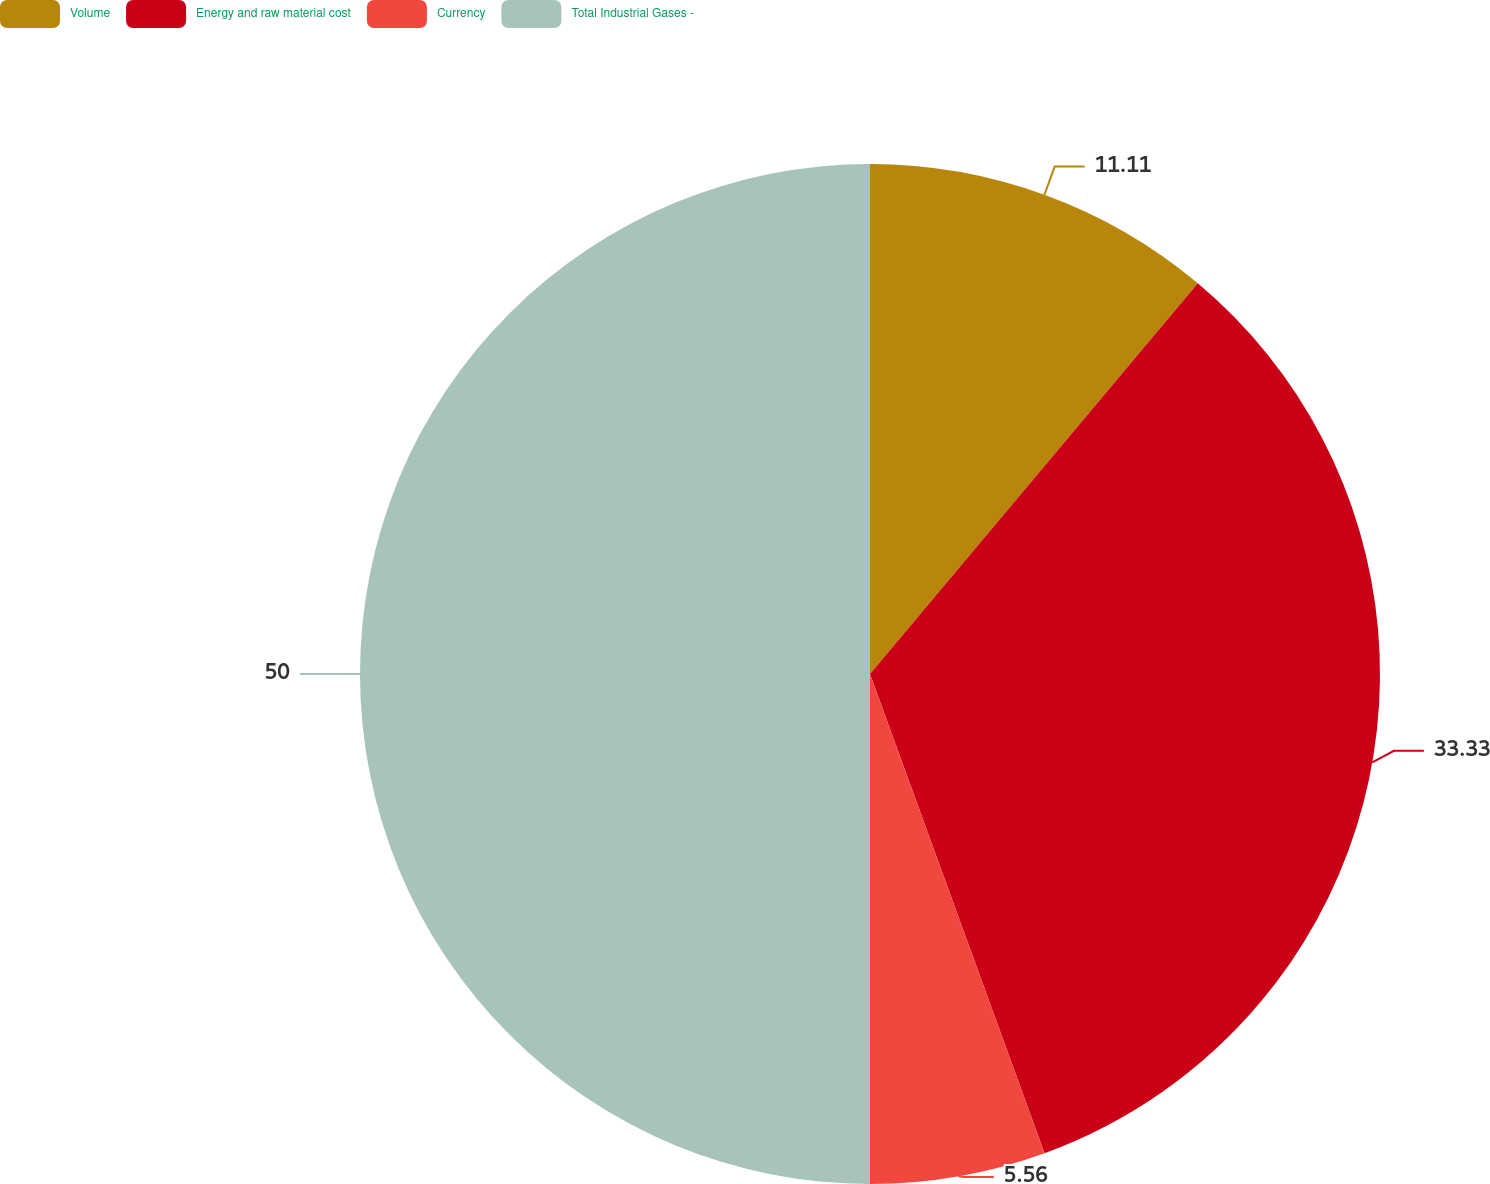Convert chart. <chart><loc_0><loc_0><loc_500><loc_500><pie_chart><fcel>Volume<fcel>Energy and raw material cost<fcel>Currency<fcel>Total Industrial Gases -<nl><fcel>11.11%<fcel>33.33%<fcel>5.56%<fcel>50.0%<nl></chart> 